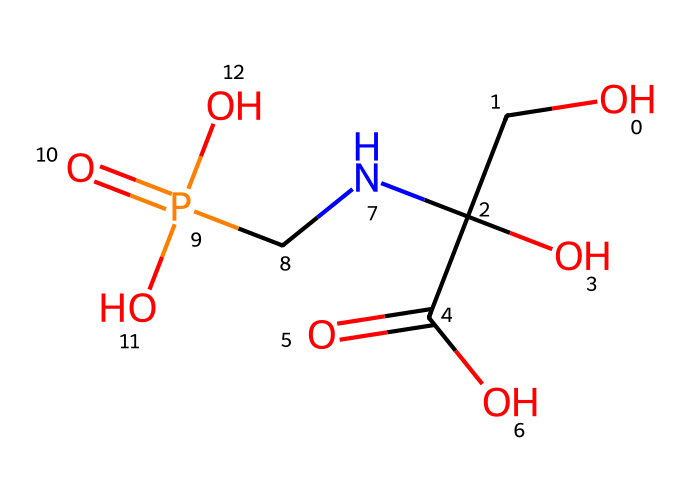What is the main functional group in glyphosate? The main functional group present in glyphosate is the carboxylic acid group, indicated by the -COOH present in the structure.
Answer: carboxylic acid How many carbon atoms are in glyphosate? By analyzing the structure, there are four carbon atoms present in the glyphosate molecule, as counted in the SMILES representation.
Answer: four What type of chemical is glyphosate classified as? Glyphosate is classified as an herbicide, which is a type of chemical used to kill unwanted plants or weeds.
Answer: herbicide What is the molecular weight of glyphosate? Based on the common information about glyphosate’s molecular formula (C3H8N5O5P), its molecular weight is calculated to be approximately 169.07 g/mol.
Answer: 169.07 Does glyphosate contain any nitrogen atoms? Yes, the structure includes one nitrogen atom based on the presence of the amino group (-NH) in the glyphosate molecule.
Answer: yes How many functional groups are present in glyphosate? Glyphosate contains four functional groups: one carboxylic acid, one phosphate, and two amine groups.
Answer: four Is glyphosate an organic or inorganic compound? Glyphosate is classified as an organic compound due to its carbon-based structure and the presence of carbon-containing functional groups.
Answer: organic 